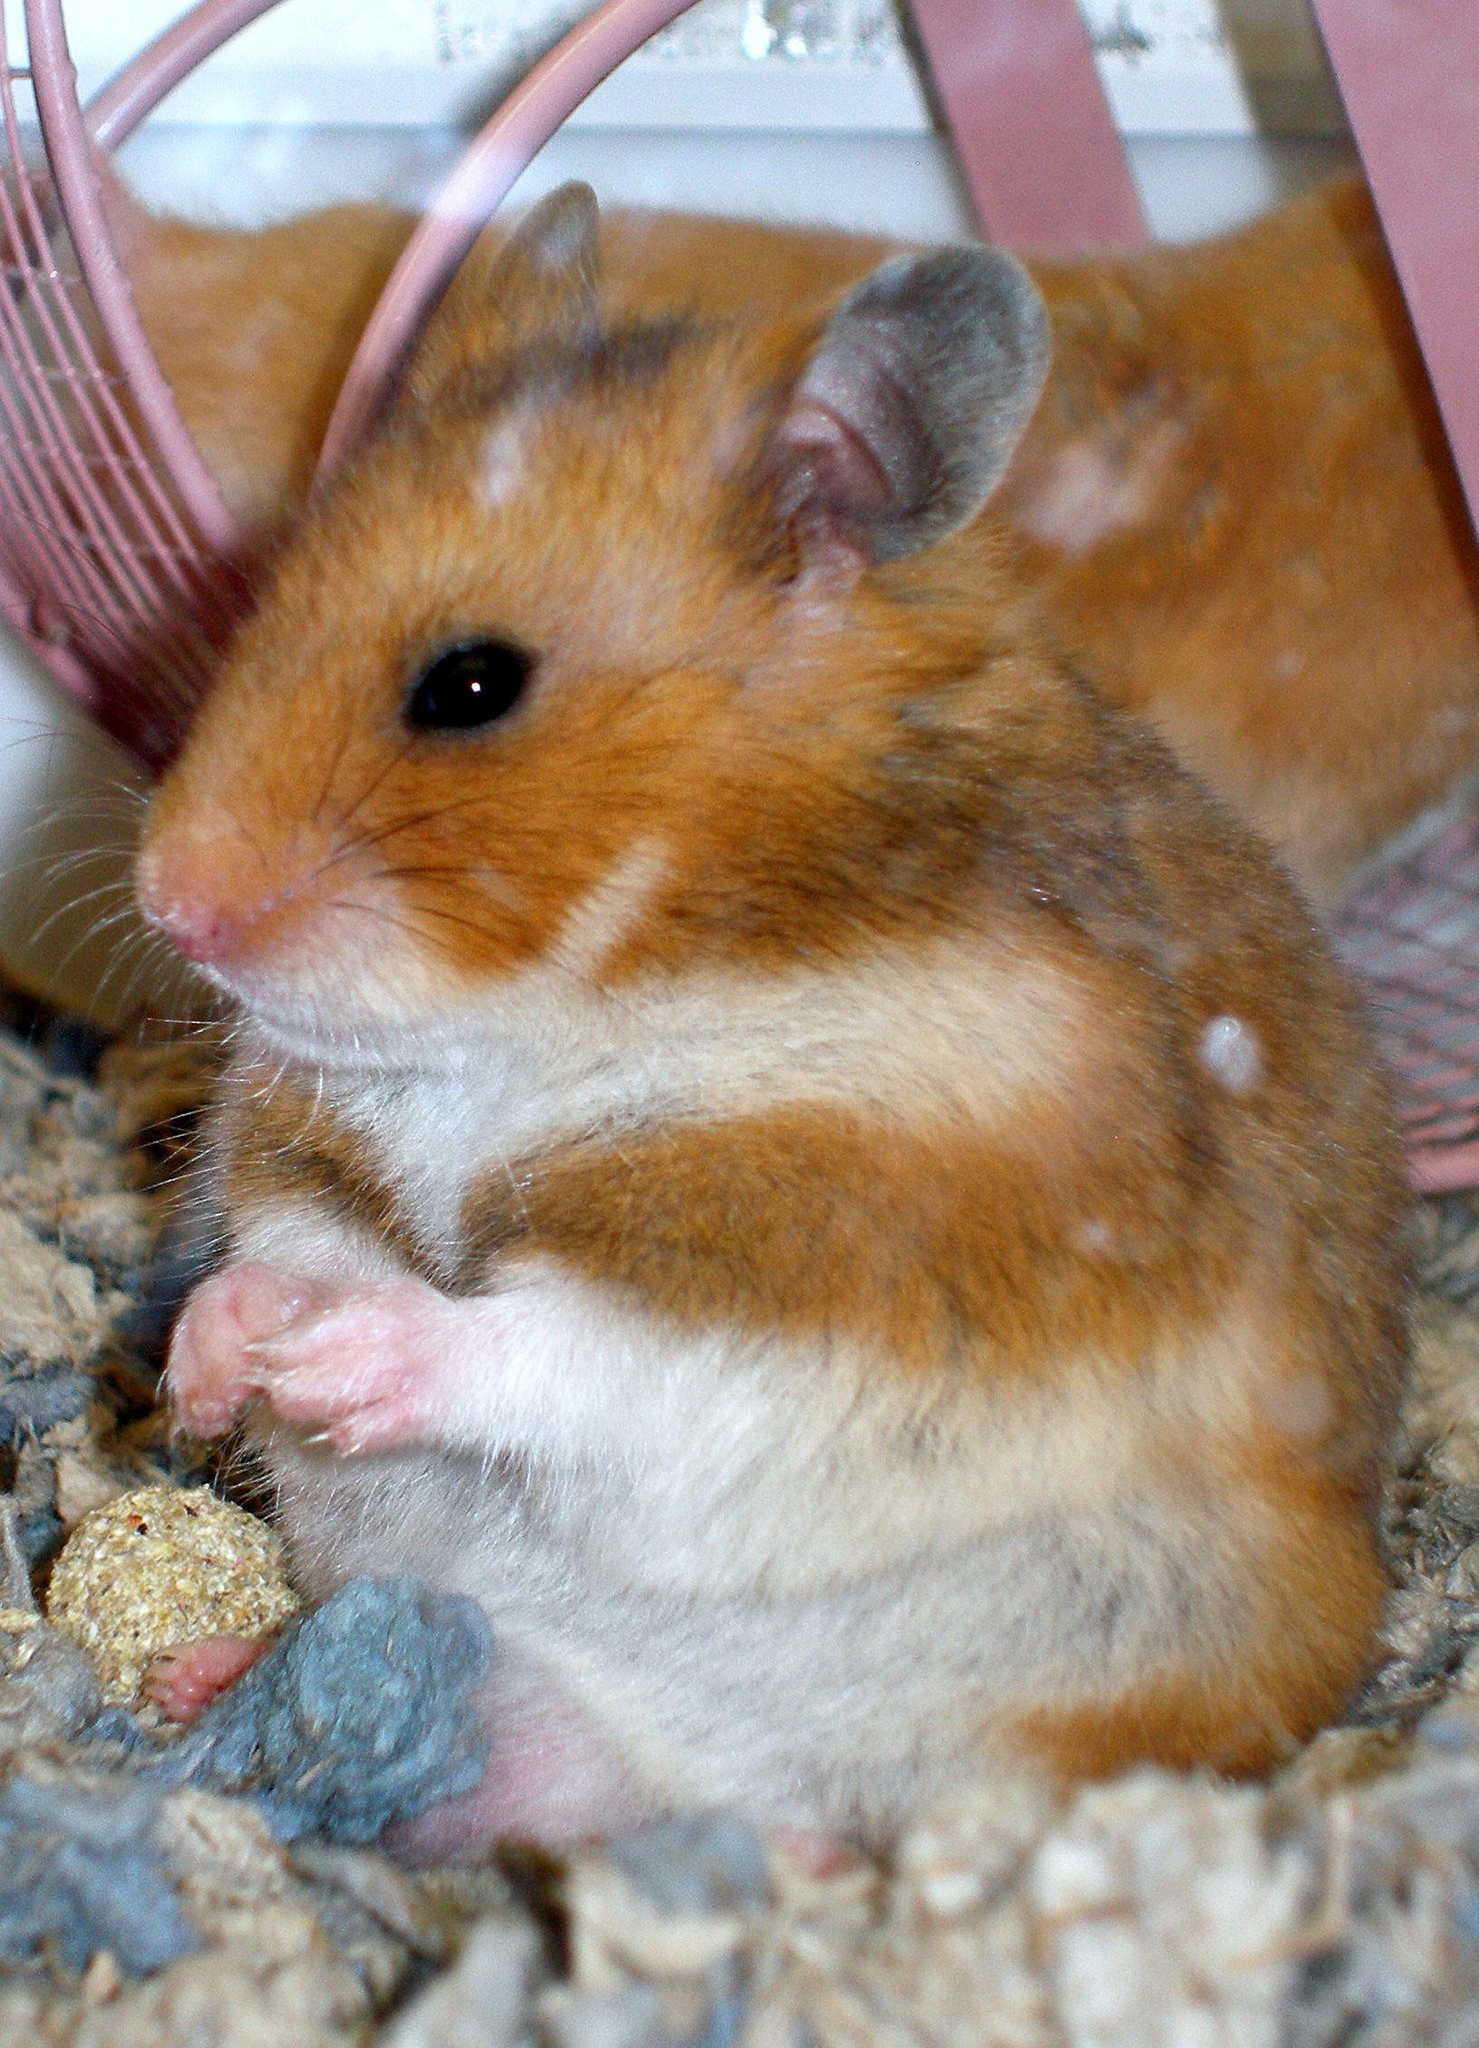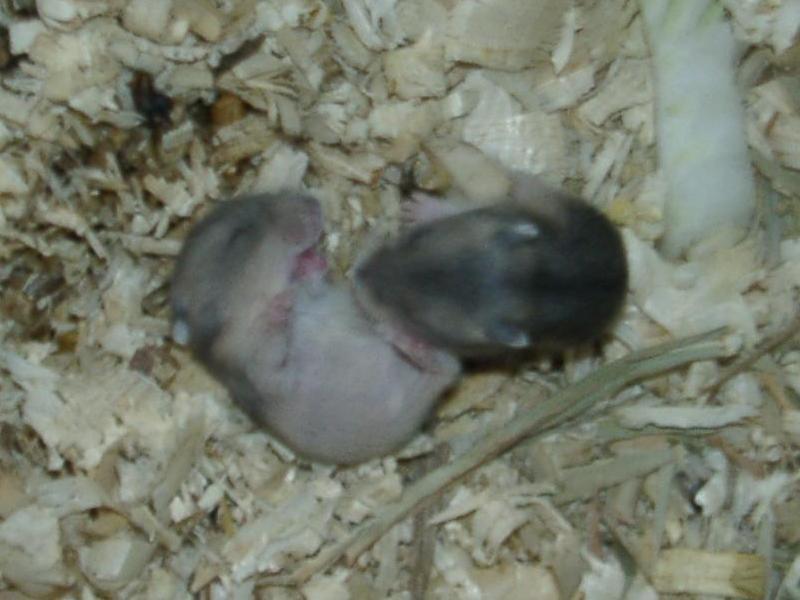The first image is the image on the left, the second image is the image on the right. For the images shown, is this caption "An image contains at least one blackish newborn rodent." true? Answer yes or no. Yes. 